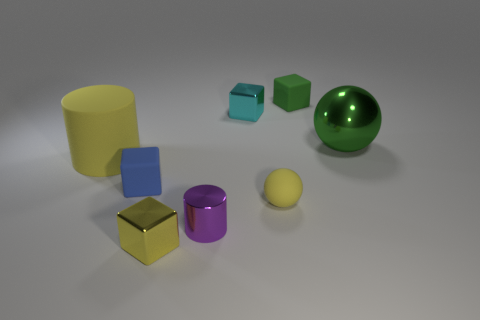Subtract 1 blocks. How many blocks are left? 3 Add 1 small yellow matte spheres. How many objects exist? 9 Subtract all cylinders. How many objects are left? 6 Add 8 small spheres. How many small spheres are left? 9 Add 6 tiny purple objects. How many tiny purple objects exist? 7 Subtract 1 purple cylinders. How many objects are left? 7 Subtract all tiny yellow metallic things. Subtract all tiny cyan blocks. How many objects are left? 6 